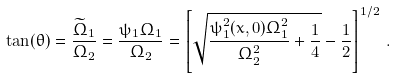Convert formula to latex. <formula><loc_0><loc_0><loc_500><loc_500>\tan ( \theta ) = \frac { \widetilde { \Omega } _ { 1 } } { \Omega _ { 2 } } = \frac { \psi _ { 1 } \Omega _ { 1 } } { \Omega _ { 2 } } = \left [ \sqrt { \frac { \psi ^ { 2 } _ { 1 } ( { x } , 0 ) \Omega _ { 1 } ^ { 2 } } { \Omega ^ { 2 } _ { 2 } } + \frac { 1 } { 4 } } - \frac { 1 } { 2 } \right ] ^ { 1 / 2 } \, .</formula> 